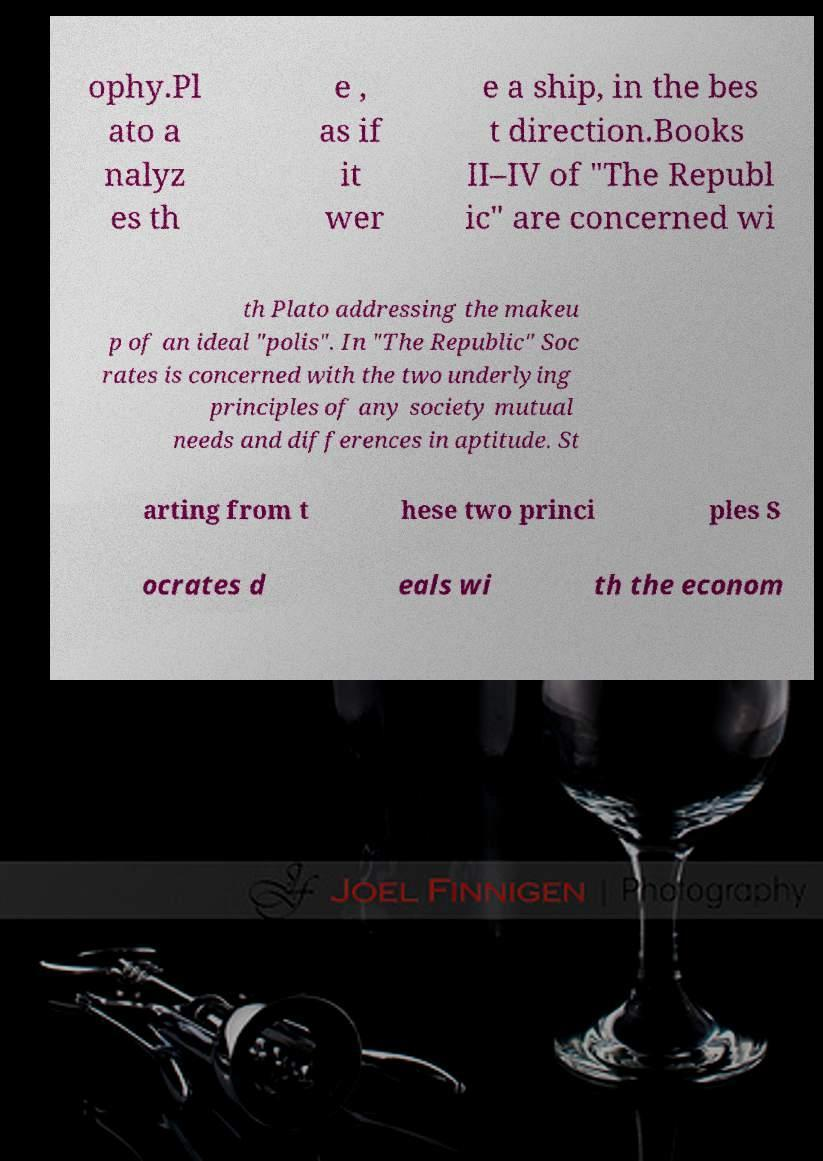What messages or text are displayed in this image? I need them in a readable, typed format. ophy.Pl ato a nalyz es th e , as if it wer e a ship, in the bes t direction.Books II–IV of "The Republ ic" are concerned wi th Plato addressing the makeu p of an ideal "polis". In "The Republic" Soc rates is concerned with the two underlying principles of any society mutual needs and differences in aptitude. St arting from t hese two princi ples S ocrates d eals wi th the econom 